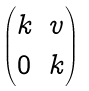Convert formula to latex. <formula><loc_0><loc_0><loc_500><loc_500>\begin{pmatrix} k & v \\ 0 & k \end{pmatrix}</formula> 